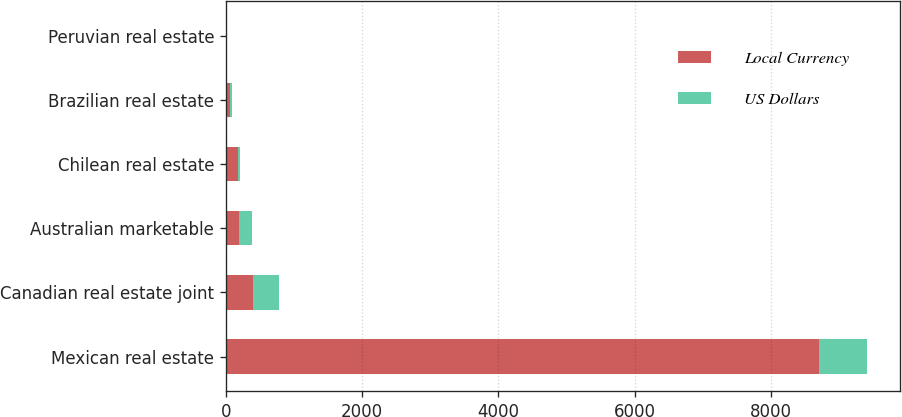<chart> <loc_0><loc_0><loc_500><loc_500><stacked_bar_chart><ecel><fcel>Mexican real estate<fcel>Canadian real estate joint<fcel>Australian marketable<fcel>Chilean real estate<fcel>Brazilian real estate<fcel>Peruvian real estate<nl><fcel>Local Currency<fcel>8715<fcel>391.6<fcel>196<fcel>182.3<fcel>55.7<fcel>7.1<nl><fcel>US Dollars<fcel>705.7<fcel>392.5<fcel>182.3<fcel>27.7<fcel>33.4<fcel>2.5<nl></chart> 